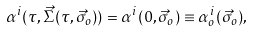Convert formula to latex. <formula><loc_0><loc_0><loc_500><loc_500>\alpha ^ { i } ( \tau , \vec { \Sigma } ( \tau , \vec { \sigma } _ { o } ) ) = \alpha ^ { i } ( 0 , \vec { \sigma } _ { o } ) \equiv \alpha _ { o } ^ { i } ( \vec { \sigma } _ { o } ) ,</formula> 